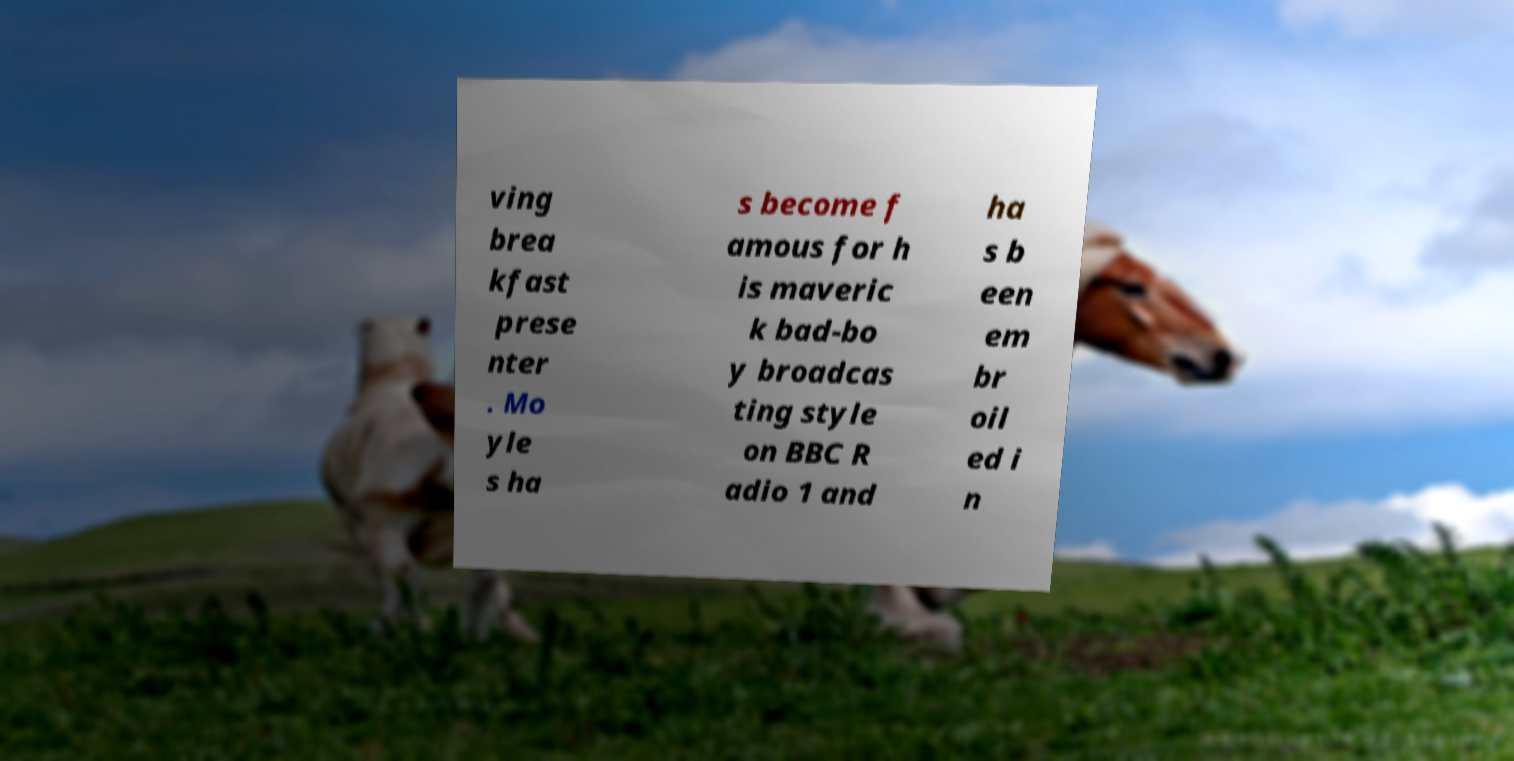Could you extract and type out the text from this image? ving brea kfast prese nter . Mo yle s ha s become f amous for h is maveric k bad-bo y broadcas ting style on BBC R adio 1 and ha s b een em br oil ed i n 